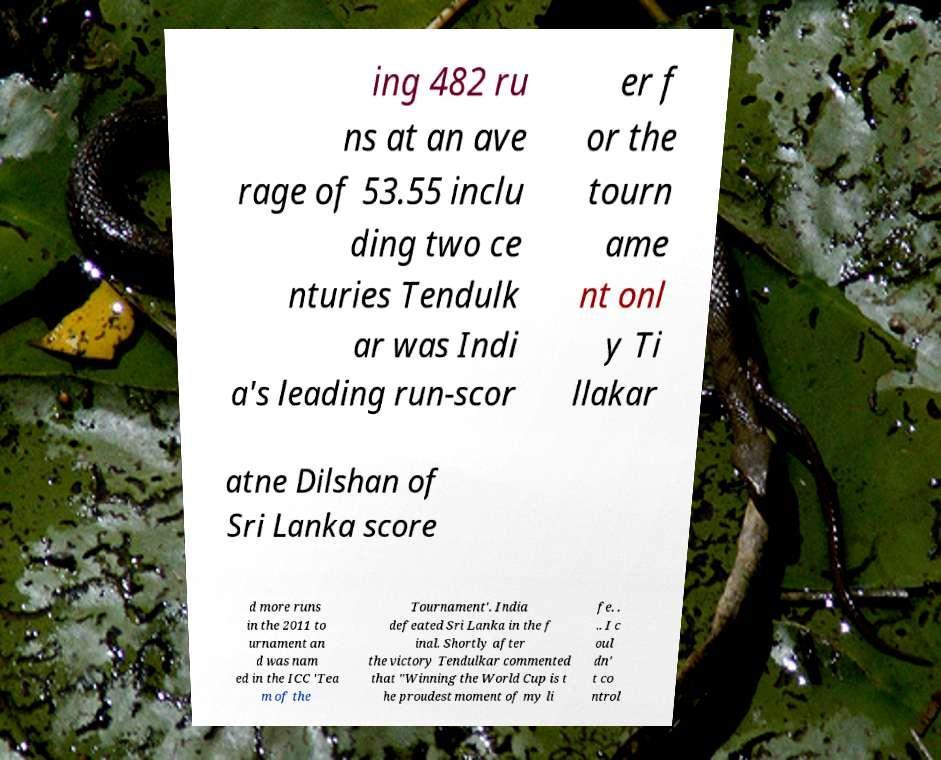Please read and relay the text visible in this image. What does it say? ing 482 ru ns at an ave rage of 53.55 inclu ding two ce nturies Tendulk ar was Indi a's leading run-scor er f or the tourn ame nt onl y Ti llakar atne Dilshan of Sri Lanka score d more runs in the 2011 to urnament an d was nam ed in the ICC 'Tea m of the Tournament'. India defeated Sri Lanka in the f inal. Shortly after the victory Tendulkar commented that "Winning the World Cup is t he proudest moment of my li fe. . .. I c oul dn' t co ntrol 